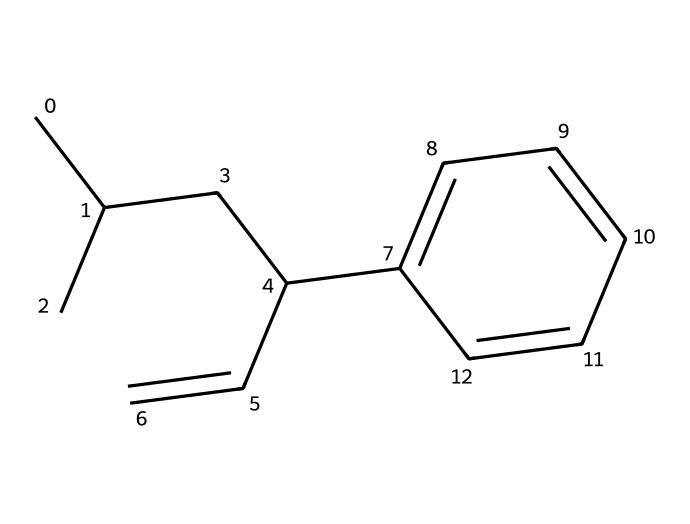What is the molecular formula of this compound? The SMILES representation indicates the number and type of atoms present in the structure. Analyzing the SMILES reveals five carbon atoms in the straight chain and an additional ring structure, totaling ten carbon atoms (C). There are also two hydrogen atoms in the double bond, and consequently, the hydrogen count is determined to be twelve, leading to the molecular formula C10H12.
Answer: C10H12 How many double bonds are present in this compound? The structure represented in the SMILES shows one double bond between the carbons (C=C) in the chain. By counting the visible double bonds in the chemical structure, we find there is only one.
Answer: 1 What type of hydrocarbon is indicated by the presence of the benzene ring? The presence of a benzene ring in the structure indicates that this chemical is an aromatic hydrocarbon. Aromatic compounds are characterized by one or more benzene rings, which consist of delocalized pi electrons. Thus, due to the benzene ring's presence, this compound is classified as aromatic.
Answer: aromatic Which part of the molecule contributes to its potential reactivity in organosulfur compounds? Organosulfur compounds often exhibit functional groups that contain sulfur. However, the chemical in this instance does not explicitly contain a sulfur atom visible in its structure, marking it more as a hydrocarbon with aromatic characteristics. Therefore, the potential reactivity in organosulfur compounds typically would stem from the sulfur-containing part, which is absent here.
Answer: absent What is the primary structural feature that suggests a role in synthetic rubber production? The presence of the alkene (C=C) bond in this compound indicates its polymerizability, which is a key feature for synthetic rubber materials. This double bond is crucial for the polymerization process that leads to the formation of long-chain polymers, essential in synthetic rubber production for wartime uses.
Answer: C=C bond How many rings are present in this chemical structure? The SMILES representation contains a benzene ring, which counts as one ring in the structure. In this chemical, only the one benzene ring is present. Therefore, counting all rings gives us a total of one.
Answer: 1 